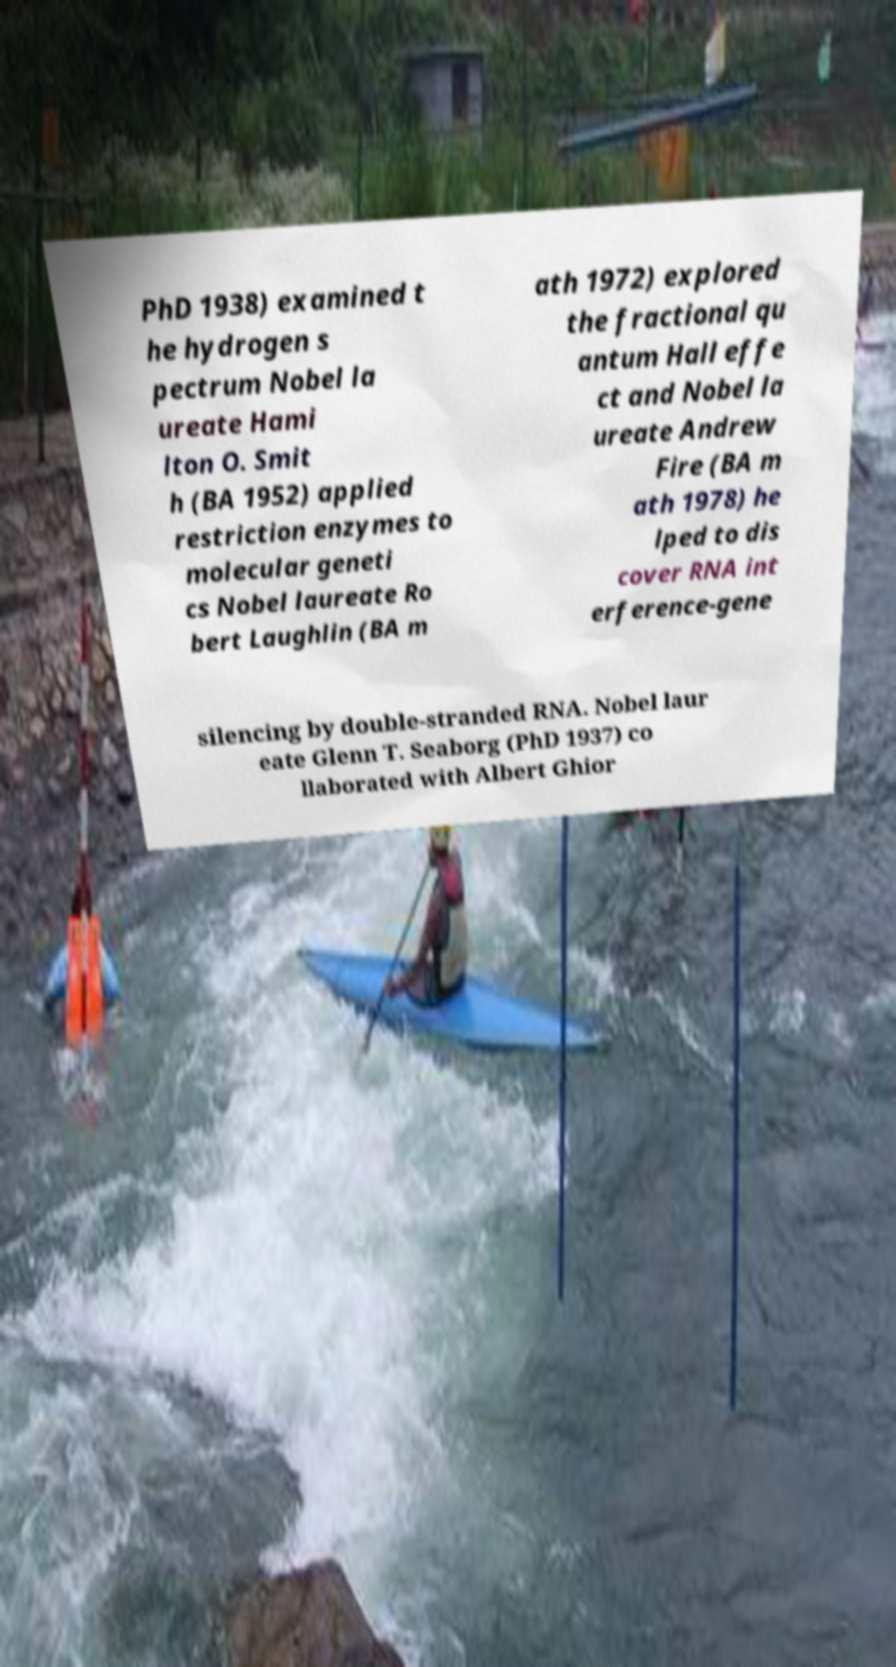For documentation purposes, I need the text within this image transcribed. Could you provide that? PhD 1938) examined t he hydrogen s pectrum Nobel la ureate Hami lton O. Smit h (BA 1952) applied restriction enzymes to molecular geneti cs Nobel laureate Ro bert Laughlin (BA m ath 1972) explored the fractional qu antum Hall effe ct and Nobel la ureate Andrew Fire (BA m ath 1978) he lped to dis cover RNA int erference-gene silencing by double-stranded RNA. Nobel laur eate Glenn T. Seaborg (PhD 1937) co llaborated with Albert Ghior 